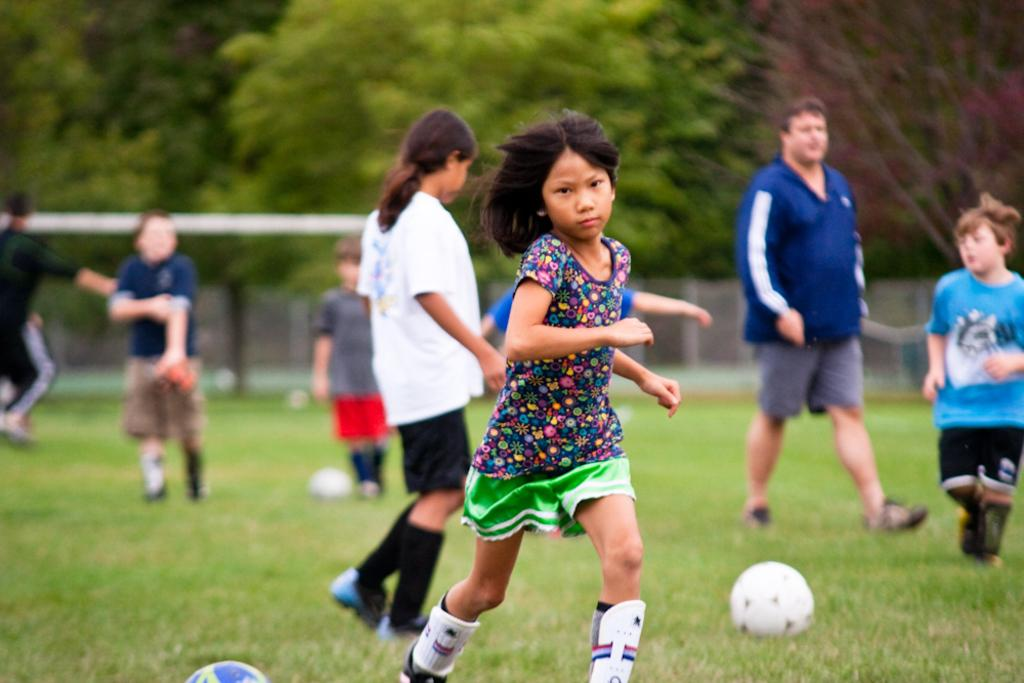What is the main subject of the image? There is a group of people in the image. What objects are on the grass in the image? There are balls on the grass in the image. What type of surface is visible in the image? There is grass visible in the image. What can be seen in the background of the image? There is a metal rod and trees in the background of the image. What type of door can be seen in the image? There is no door present in the image. How much butter is being used by the group of people in the image? There is no butter visible in the image, and the group of people are not using any butter. 